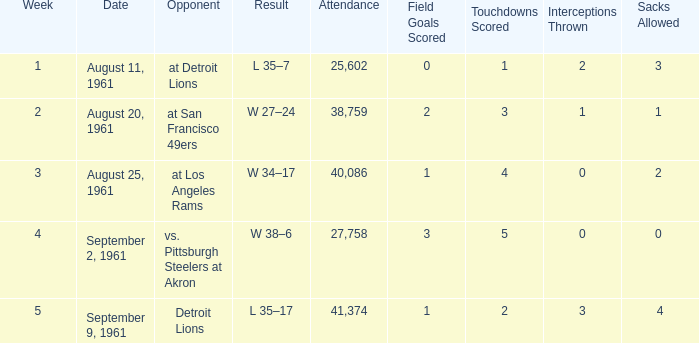What was the score of the Browns week 4 game? W 38–6. 